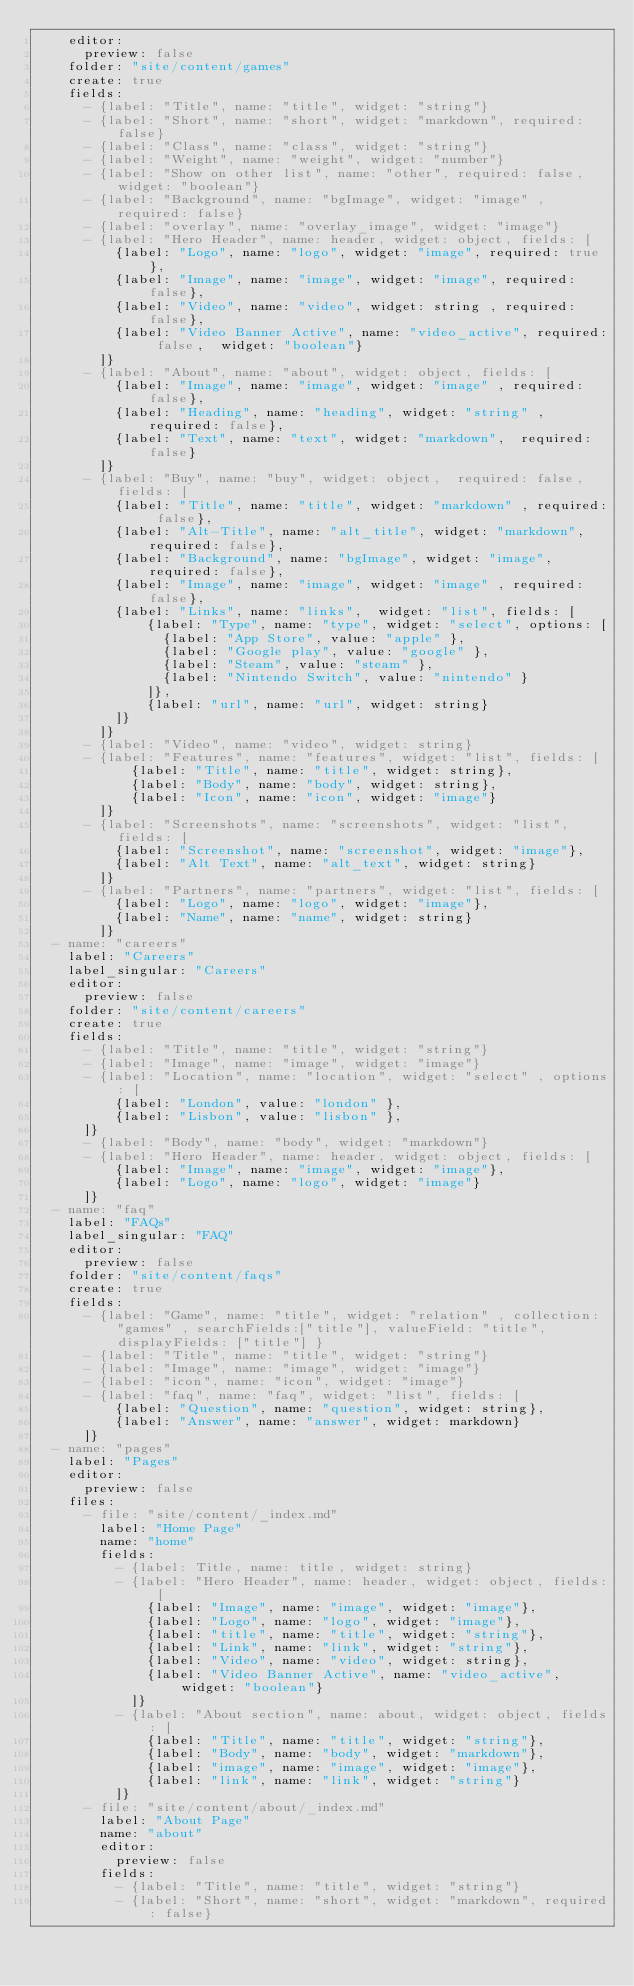Convert code to text. <code><loc_0><loc_0><loc_500><loc_500><_YAML_>    editor:
      preview: false
    folder: "site/content/games"
    create: true
    fields:
      - {label: "Title", name: "title", widget: "string"}
      - {label: "Short", name: "short", widget: "markdown", required: false}
      - {label: "Class", name: "class", widget: "string"}
      - {label: "Weight", name: "weight", widget: "number"}
      - {label: "Show on other list", name: "other", required: false,  widget: "boolean"}
      - {label: "Background", name: "bgImage", widget: "image" , required: false}
      - {label: "overlay", name: "overlay_image", widget: "image"}
      - {label: "Hero Header", name: header, widget: object, fields: [
          {label: "Logo", name: "logo", widget: "image", required: true},
          {label: "Image", name: "image", widget: "image", required: false},
          {label: "Video", name: "video", widget: string , required: false},
          {label: "Video Banner Active", name: "video_active", required: false,  widget: "boolean"}
        ]}
      - {label: "About", name: "about", widget: object, fields: [
          {label: "Image", name: "image", widget: "image" , required: false},
          {label: "Heading", name: "heading", widget: "string" , required: false},
          {label: "Text", name: "text", widget: "markdown",  required: false}
        ]}
      - {label: "Buy", name: "buy", widget: object,  required: false, fields: [
          {label: "Title", name: "title", widget: "markdown" , required: false},
          {label: "Alt-Title", name: "alt_title", widget: "markdown", required: false},
          {label: "Background", name: "bgImage", widget: "image", required: false},
          {label: "Image", name: "image", widget: "image" , required: false},
          {label: "Links", name: "links",  widget: "list", fields: [
              {label: "Type", name: "type", widget: "select", options: [
                {label: "App Store", value: "apple" },
                {label: "Google play", value: "google" },
                {label: "Steam", value: "steam" },
                {label: "Nintendo Switch", value: "nintendo" }
              ]},
              {label: "url", name: "url", widget: string}
          ]}
        ]}
      - {label: "Video", name: "video", widget: string}
      - {label: "Features", name: "features", widget: "list", fields: [
            {label: "Title", name: "title", widget: string},
            {label: "Body", name: "body", widget: string},
            {label: "Icon", name: "icon", widget: "image"}
        ]}
      - {label: "Screenshots", name: "screenshots", widget: "list", fields: [
          {label: "Screenshot", name: "screenshot", widget: "image"},
          {label: "Alt Text", name: "alt_text", widget: string}
        ]}
      - {label: "Partners", name: "partners", widget: "list", fields: [
          {label: "Logo", name: "logo", widget: "image"},
          {label: "Name", name: "name", widget: string}
        ]}
  - name: "careers"
    label: "Careers"
    label_singular: "Careers"
    editor:
      preview: false
    folder: "site/content/careers"
    create: true
    fields:
      - {label: "Title", name: "title", widget: "string"}
      - {label: "Image", name: "image", widget: "image"}
      - {label: "Location", name: "location", widget: "select" , options: [
          {label: "London", value: "london" },
          {label: "Lisbon", value: "lisbon" },
      ]}
      - {label: "Body", name: "body", widget: "markdown"}
      - {label: "Hero Header", name: header, widget: object, fields: [
          {label: "Image", name: "image", widget: "image"},
          {label: "Logo", name: "logo", widget: "image"}
      ]}
  - name: "faq"
    label: "FAQs"
    label_singular: "FAQ"
    editor:
      preview: false
    folder: "site/content/faqs"
    create: true
    fields:
      - {label: "Game", name: "title", widget: "relation" , collection: "games" , searchFields:["title"], valueField: "title", displayFields: ["title"] }
      - {label: "Title", name: "title", widget: "string"}
      - {label: "Image", name: "image", widget: "image"}
      - {label: "icon", name: "icon", widget: "image"}
      - {label: "faq", name: "faq", widget: "list", fields: [
          {label: "Question", name: "question", widget: string},
          {label: "Answer", name: "answer", widget: markdown}
      ]}
  - name: "pages"
    label: "Pages"
    editor:
      preview: false
    files:
      - file: "site/content/_index.md"
        label: "Home Page"
        name: "home"
        fields:
          - {label: Title, name: title, widget: string}
          - {label: "Hero Header", name: header, widget: object, fields: [
              {label: "Image", name: "image", widget: "image"},
              {label: "Logo", name: "logo", widget: "image"},
              {label: "title", name: "title", widget: "string"},
              {label: "Link", name: "link", widget: "string"},
              {label: "Video", name: "video", widget: string},
              {label: "Video Banner Active", name: "video_active", widget: "boolean"}
            ]}
          - {label: "About section", name: about, widget: object, fields: [
              {label: "Title", name: "title", widget: "string"},
              {label: "Body", name: "body", widget: "markdown"},
              {label: "image", name: "image", widget: "image"},
              {label: "link", name: "link", widget: "string"}
          ]}
      - file: "site/content/about/_index.md"
        label: "About Page"
        name: "about"
        editor:
          preview: false
        fields:
          - {label: "Title", name: "title", widget: "string"}
          - {label: "Short", name: "short", widget: "markdown", required: false}</code> 